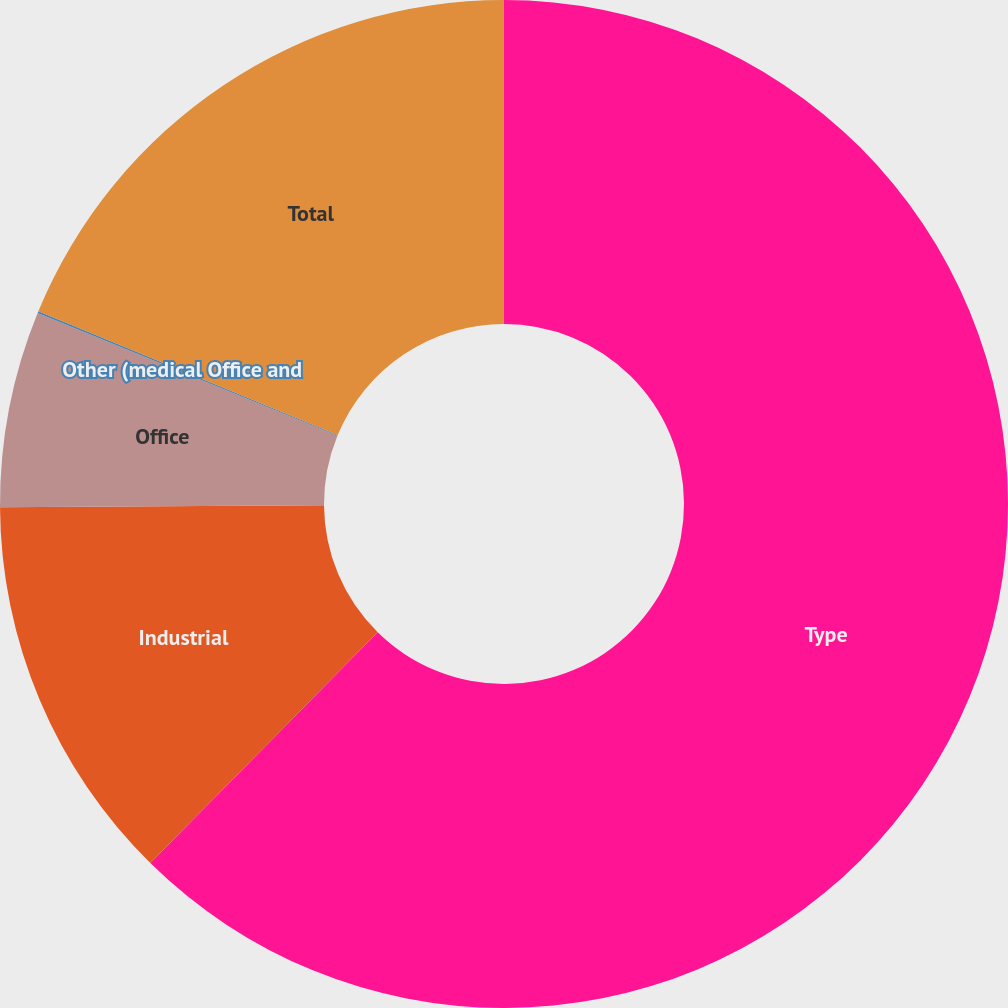Convert chart to OTSL. <chart><loc_0><loc_0><loc_500><loc_500><pie_chart><fcel>Type<fcel>Industrial<fcel>Office<fcel>Other (medical Office and<fcel>Total<nl><fcel>62.38%<fcel>12.52%<fcel>6.29%<fcel>0.06%<fcel>18.75%<nl></chart> 